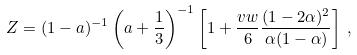Convert formula to latex. <formula><loc_0><loc_0><loc_500><loc_500>Z = ( 1 - a ) ^ { - 1 } \left ( a + \frac { 1 } { 3 } \right ) ^ { - 1 } \left [ 1 + \frac { v w } { 6 } \frac { ( 1 - 2 \alpha ) ^ { 2 } } { \alpha ( 1 - \alpha ) } \right ] \, ,</formula> 